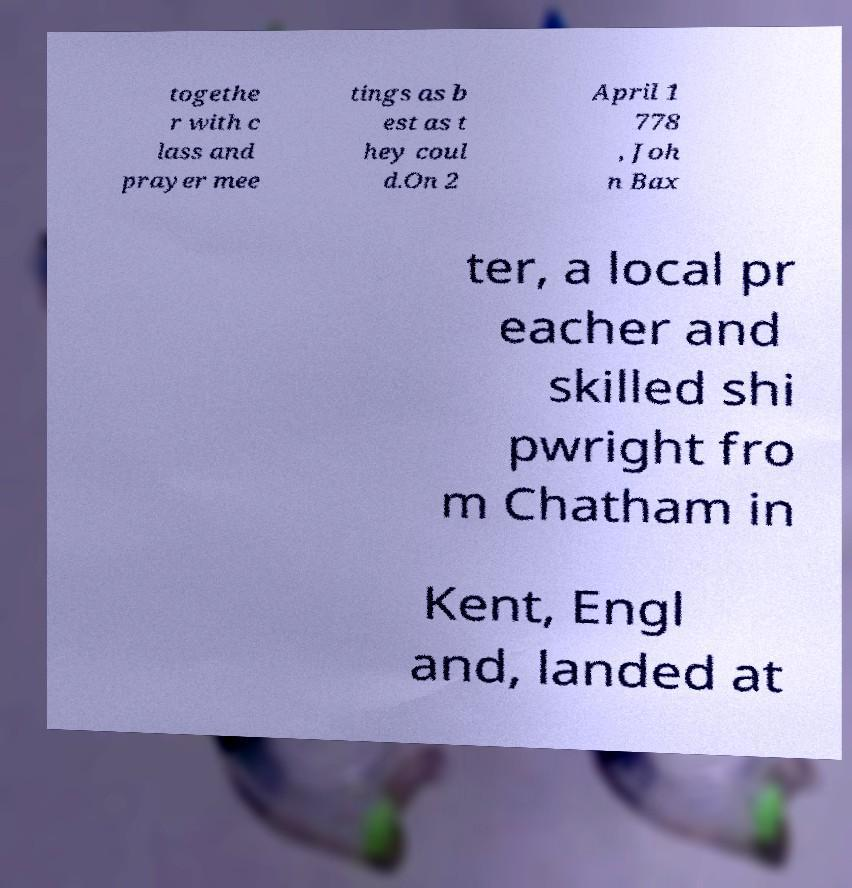Please read and relay the text visible in this image. What does it say? togethe r with c lass and prayer mee tings as b est as t hey coul d.On 2 April 1 778 , Joh n Bax ter, a local pr eacher and skilled shi pwright fro m Chatham in Kent, Engl and, landed at 